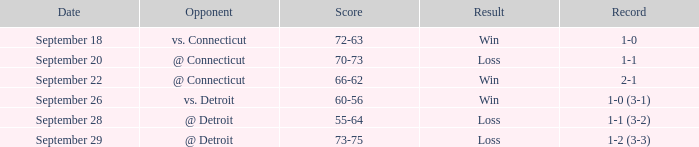WHAT IS THE OPPONENT WITH A SCORE OF 72-63? Vs. connecticut. 